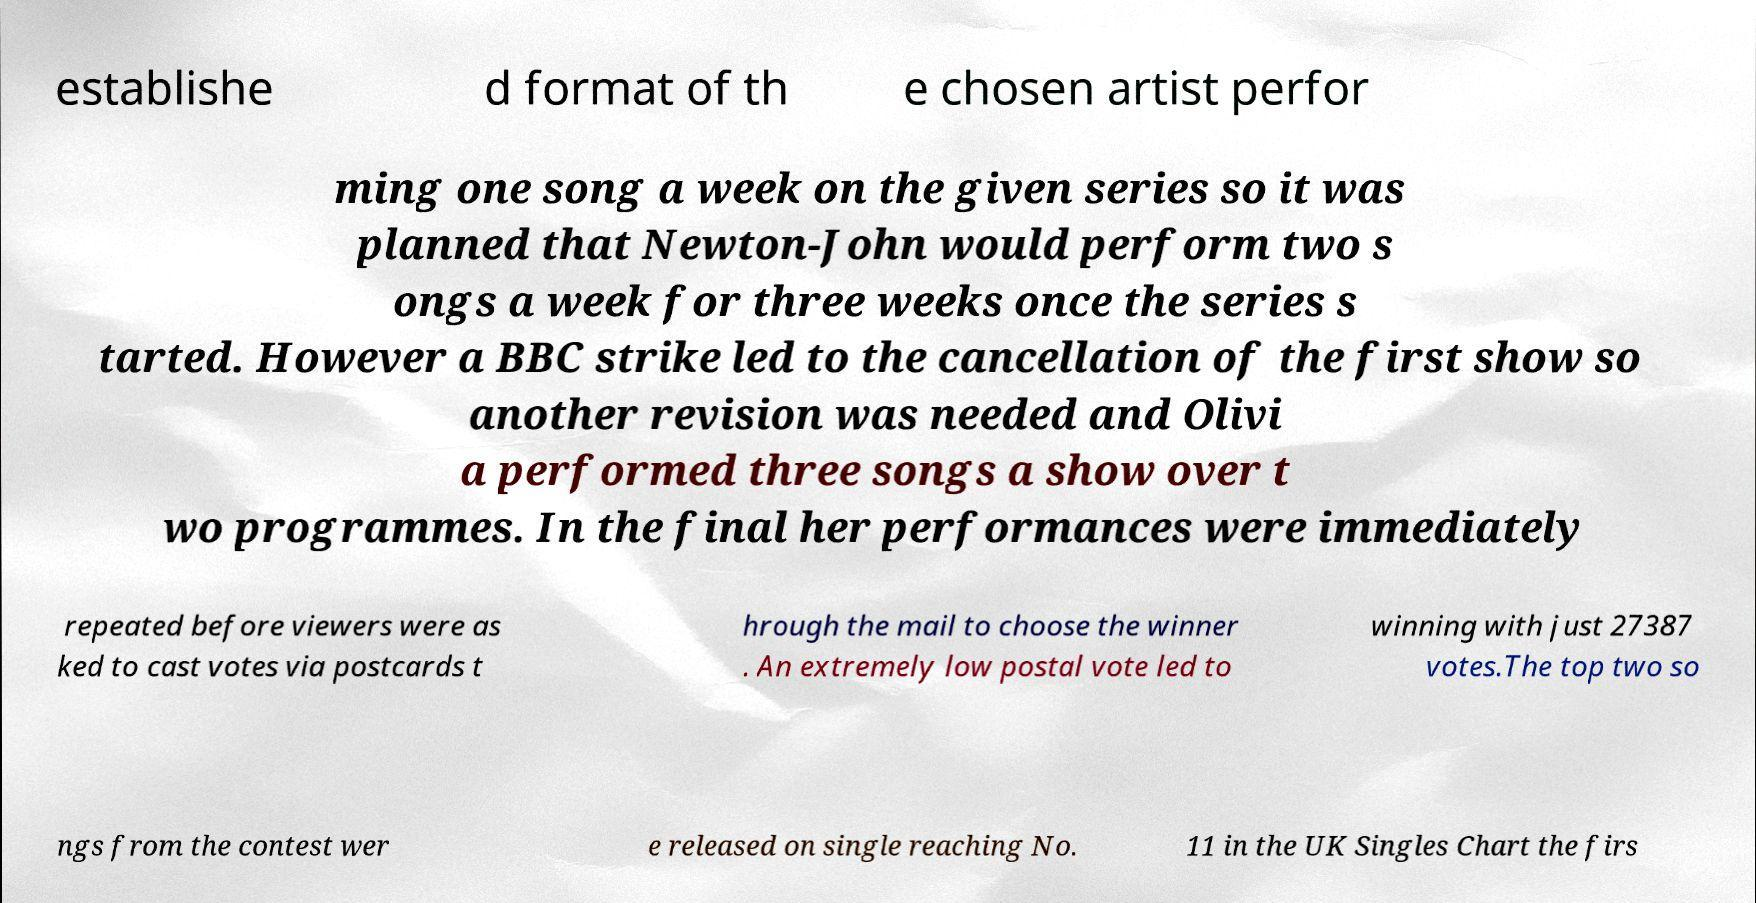Could you extract and type out the text from this image? establishe d format of th e chosen artist perfor ming one song a week on the given series so it was planned that Newton-John would perform two s ongs a week for three weeks once the series s tarted. However a BBC strike led to the cancellation of the first show so another revision was needed and Olivi a performed three songs a show over t wo programmes. In the final her performances were immediately repeated before viewers were as ked to cast votes via postcards t hrough the mail to choose the winner . An extremely low postal vote led to winning with just 27387 votes.The top two so ngs from the contest wer e released on single reaching No. 11 in the UK Singles Chart the firs 